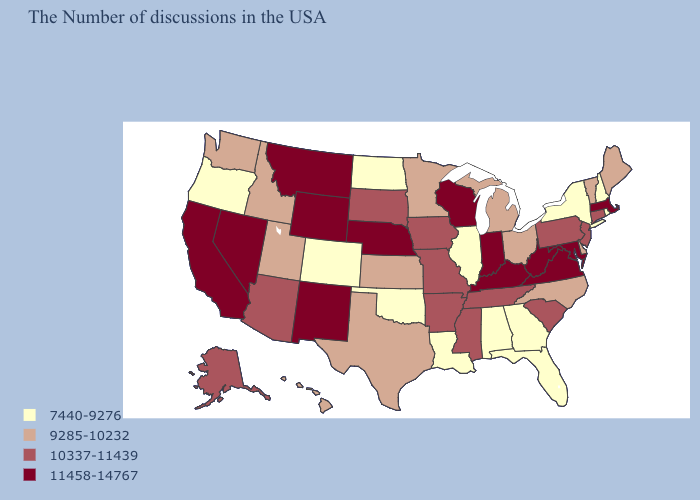Among the states that border North Dakota , does South Dakota have the lowest value?
Give a very brief answer. No. What is the highest value in the USA?
Write a very short answer. 11458-14767. Among the states that border Connecticut , which have the highest value?
Concise answer only. Massachusetts. What is the value of Connecticut?
Short answer required. 10337-11439. What is the value of Georgia?
Be succinct. 7440-9276. What is the highest value in the MidWest ?
Write a very short answer. 11458-14767. How many symbols are there in the legend?
Write a very short answer. 4. What is the lowest value in the South?
Answer briefly. 7440-9276. What is the value of Wyoming?
Quick response, please. 11458-14767. Does the map have missing data?
Short answer required. No. Which states have the highest value in the USA?
Answer briefly. Massachusetts, Maryland, Virginia, West Virginia, Kentucky, Indiana, Wisconsin, Nebraska, Wyoming, New Mexico, Montana, Nevada, California. Among the states that border Colorado , does Nebraska have the highest value?
Answer briefly. Yes. Among the states that border Illinois , which have the lowest value?
Write a very short answer. Missouri, Iowa. Is the legend a continuous bar?
Write a very short answer. No. 